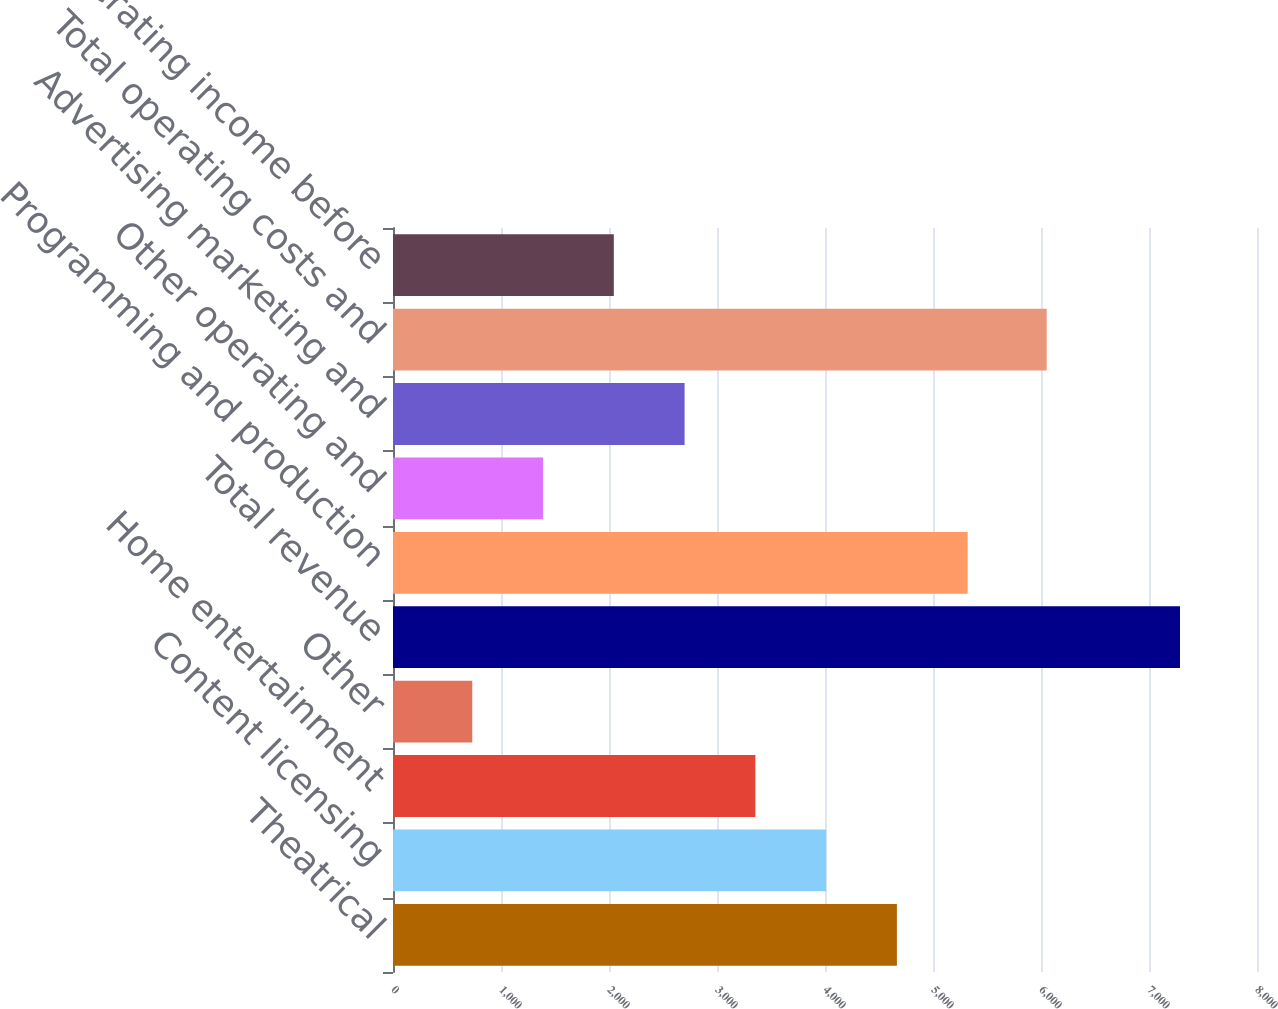Convert chart. <chart><loc_0><loc_0><loc_500><loc_500><bar_chart><fcel>Theatrical<fcel>Content licensing<fcel>Home entertainment<fcel>Other<fcel>Total revenue<fcel>Programming and production<fcel>Other operating and<fcel>Advertising marketing and<fcel>Total operating costs and<fcel>Operating income before<nl><fcel>4665.8<fcel>4010.5<fcel>3355.2<fcel>734<fcel>7287<fcel>5321.1<fcel>1389.3<fcel>2699.9<fcel>6053<fcel>2044.6<nl></chart> 